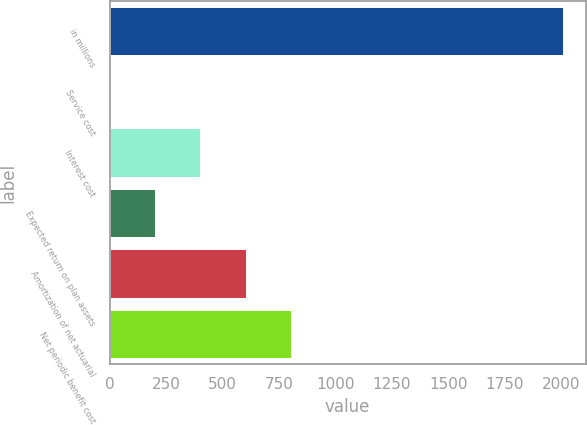Convert chart to OTSL. <chart><loc_0><loc_0><loc_500><loc_500><bar_chart><fcel>in millions<fcel>Service cost<fcel>Interest cost<fcel>Expected return on plan assets<fcel>Amortization of net actuarial<fcel>Net periodic benefit cost<nl><fcel>2007<fcel>0.1<fcel>401.48<fcel>200.79<fcel>602.17<fcel>802.86<nl></chart> 